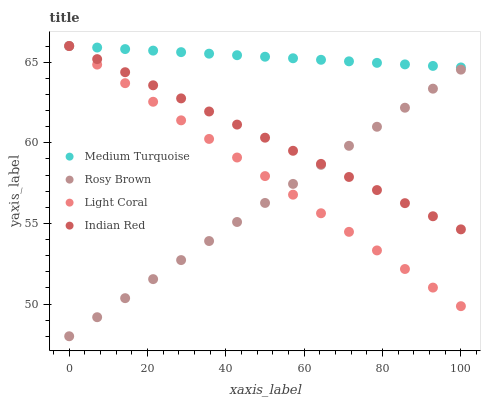Does Rosy Brown have the minimum area under the curve?
Answer yes or no. Yes. Does Medium Turquoise have the maximum area under the curve?
Answer yes or no. Yes. Does Indian Red have the minimum area under the curve?
Answer yes or no. No. Does Indian Red have the maximum area under the curve?
Answer yes or no. No. Is Rosy Brown the smoothest?
Answer yes or no. Yes. Is Medium Turquoise the roughest?
Answer yes or no. Yes. Is Indian Red the smoothest?
Answer yes or no. No. Is Indian Red the roughest?
Answer yes or no. No. Does Rosy Brown have the lowest value?
Answer yes or no. Yes. Does Indian Red have the lowest value?
Answer yes or no. No. Does Medium Turquoise have the highest value?
Answer yes or no. Yes. Does Rosy Brown have the highest value?
Answer yes or no. No. Is Rosy Brown less than Medium Turquoise?
Answer yes or no. Yes. Is Medium Turquoise greater than Rosy Brown?
Answer yes or no. Yes. Does Indian Red intersect Light Coral?
Answer yes or no. Yes. Is Indian Red less than Light Coral?
Answer yes or no. No. Is Indian Red greater than Light Coral?
Answer yes or no. No. Does Rosy Brown intersect Medium Turquoise?
Answer yes or no. No. 